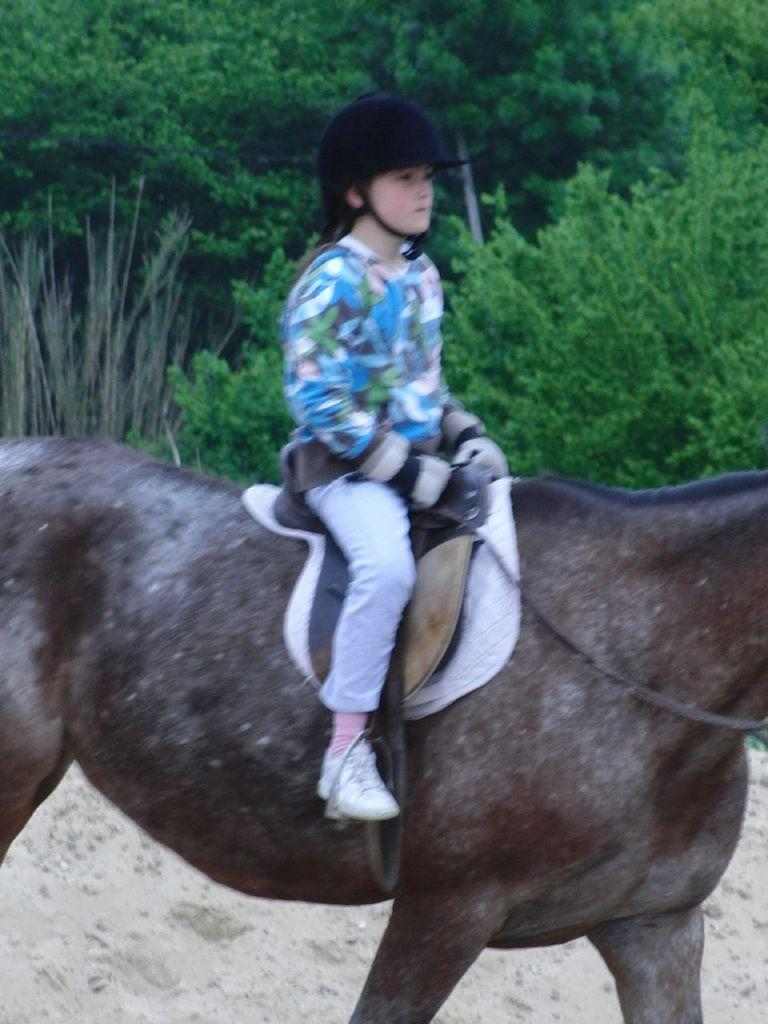Who is the main subject in the image? There is a girl in the image. What is the girl doing in the image? The girl is sitting on an animal. What can be seen in the background of the image? There are trees in the background of the image. How much sugar is the girl eating in the image? There is no sugar present in the image, and the girl is not eating anything. How many boys are visible in the image? There are no boys present in the image; only a girl and an animal are visible. 